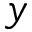Convert formula to latex. <formula><loc_0><loc_0><loc_500><loc_500>y</formula> 